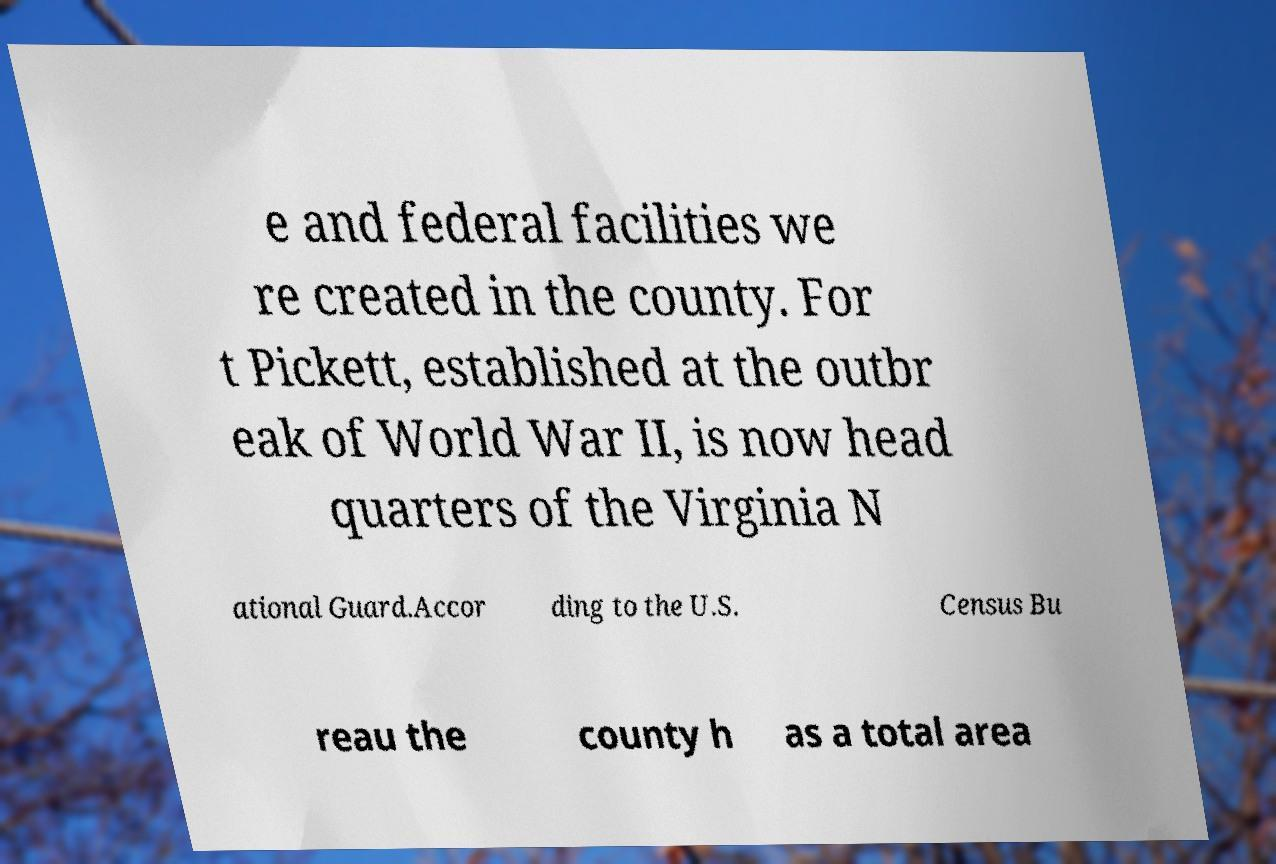Can you accurately transcribe the text from the provided image for me? e and federal facilities we re created in the county. For t Pickett, established at the outbr eak of World War II, is now head quarters of the Virginia N ational Guard.Accor ding to the U.S. Census Bu reau the county h as a total area 